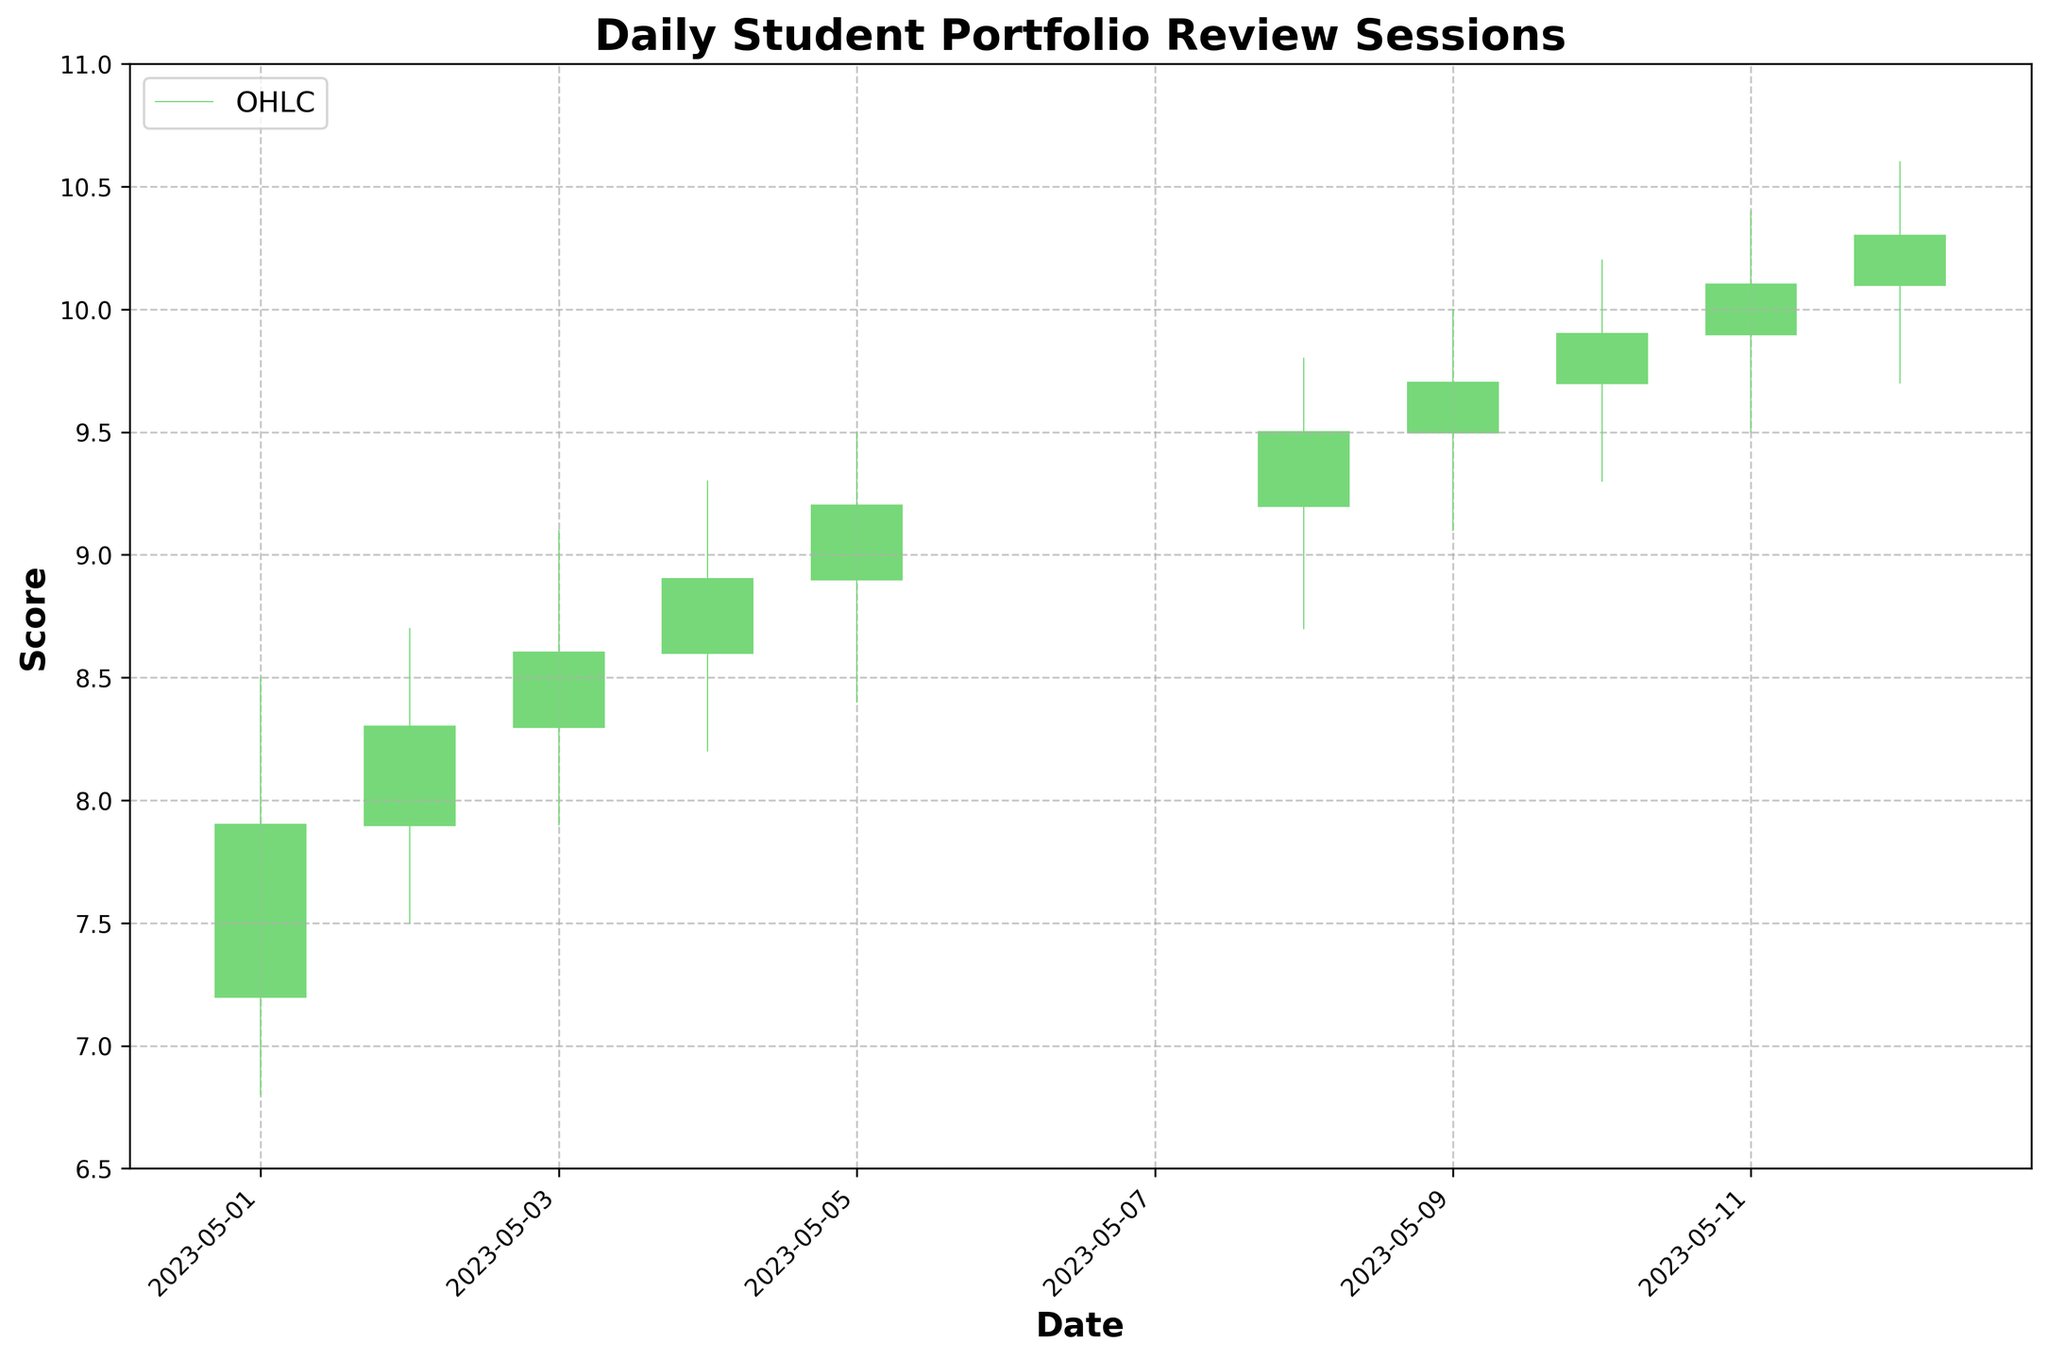what is the title of the chart? The title is generally placed at the top of the chart. In this case, it reads "Daily Student Portfolio Review Sessions".
Answer: Daily Student Portfolio Review Sessions How many days of data are illustrated in the chart? By counting the number of data points on the x-axis, which spans from "2023-05-01" to "2023-05-12", we notice there are 10 days of data illustrated.
Answer: 10 What is the color used to indicate days when the closing score is higher than the opening score? Referring to the color legend on the chart, green is used to signify days when the closing score is higher than the opening score.
Answer: Green What range of scores is displayed on the y-axis? By looking at the y-axis, the chart ranges from a minimum score of 6.5 to a maximum score of 11.
Answer: 6.5 to 11 On which date did the student have their highest portfolio review score of 10.2? Checking the high values in the OHLC bars, the highest score of 10.2 occurred on "2023-05-10".
Answer: 2023-05-10 How does the closing score on 2023-05-01 compare to the opening score on 2023-05-02? The closing score on "2023-05-01" is 7.9, and the opening score on "2023-05-02" is also 7.9, thus they are equal.
Answer: Equal Between May 8 and May 12, what was the highest score achieved? Between "2023-05-08" and "2023-05-12," the highest score can be seen by looking at the highest highs in the chart, which is 10.6 on "2023-05-12".
Answer: 10.6 Over the 10 days, what is the average closing score? Sum all closing scores (7.9 + 8.3 + 8.6 + 8.9 + 9.2 + 9.5 + 9.7 + 9.9 + 10.1 + 10.3 = 92.4) and divide by the number of days (10). The average closing score is 92.4/10.
Answer: 9.24 What trend is observed in the closing scores from May 1 to May 12? Observing the closing scores over the given dates, it seems that the scores generally increase from 7.9 on May 1 to 10.3 on May 12, indicating an upward trend.
Answer: Upward trend 